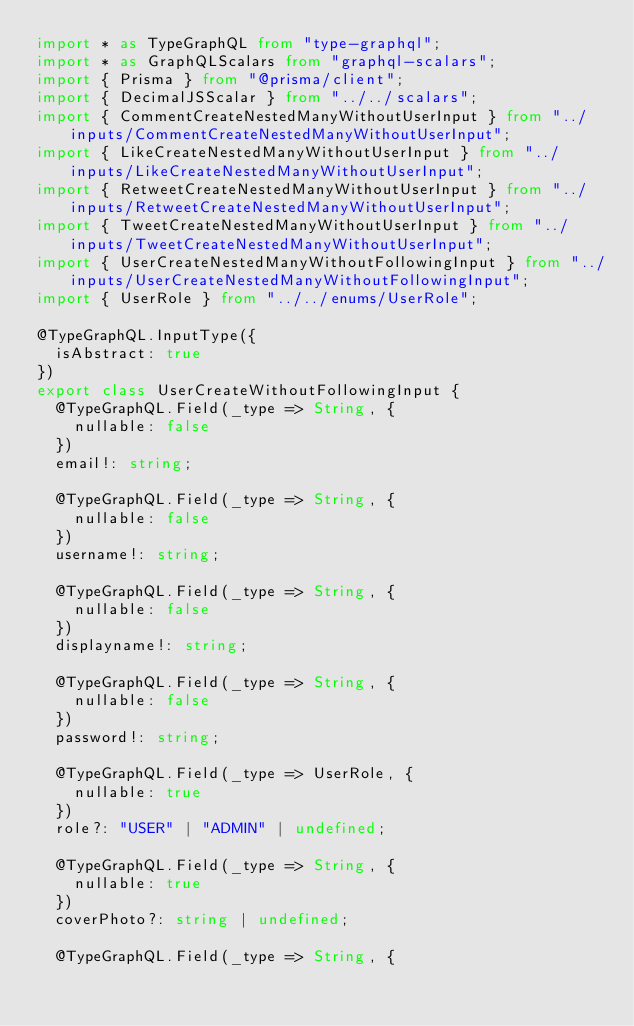<code> <loc_0><loc_0><loc_500><loc_500><_TypeScript_>import * as TypeGraphQL from "type-graphql";
import * as GraphQLScalars from "graphql-scalars";
import { Prisma } from "@prisma/client";
import { DecimalJSScalar } from "../../scalars";
import { CommentCreateNestedManyWithoutUserInput } from "../inputs/CommentCreateNestedManyWithoutUserInput";
import { LikeCreateNestedManyWithoutUserInput } from "../inputs/LikeCreateNestedManyWithoutUserInput";
import { RetweetCreateNestedManyWithoutUserInput } from "../inputs/RetweetCreateNestedManyWithoutUserInput";
import { TweetCreateNestedManyWithoutUserInput } from "../inputs/TweetCreateNestedManyWithoutUserInput";
import { UserCreateNestedManyWithoutFollowingInput } from "../inputs/UserCreateNestedManyWithoutFollowingInput";
import { UserRole } from "../../enums/UserRole";

@TypeGraphQL.InputType({
  isAbstract: true
})
export class UserCreateWithoutFollowingInput {
  @TypeGraphQL.Field(_type => String, {
    nullable: false
  })
  email!: string;

  @TypeGraphQL.Field(_type => String, {
    nullable: false
  })
  username!: string;

  @TypeGraphQL.Field(_type => String, {
    nullable: false
  })
  displayname!: string;

  @TypeGraphQL.Field(_type => String, {
    nullable: false
  })
  password!: string;

  @TypeGraphQL.Field(_type => UserRole, {
    nullable: true
  })
  role?: "USER" | "ADMIN" | undefined;

  @TypeGraphQL.Field(_type => String, {
    nullable: true
  })
  coverPhoto?: string | undefined;

  @TypeGraphQL.Field(_type => String, {</code> 